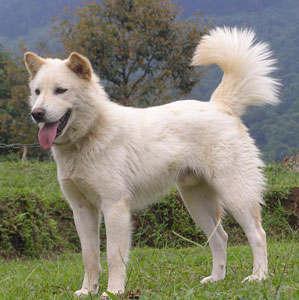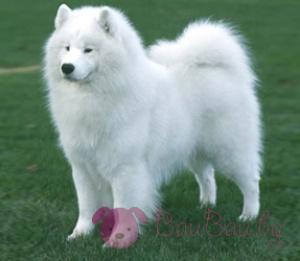The first image is the image on the left, the second image is the image on the right. Analyze the images presented: Is the assertion "One of the images shows exactly two dogs." valid? Answer yes or no. No. 